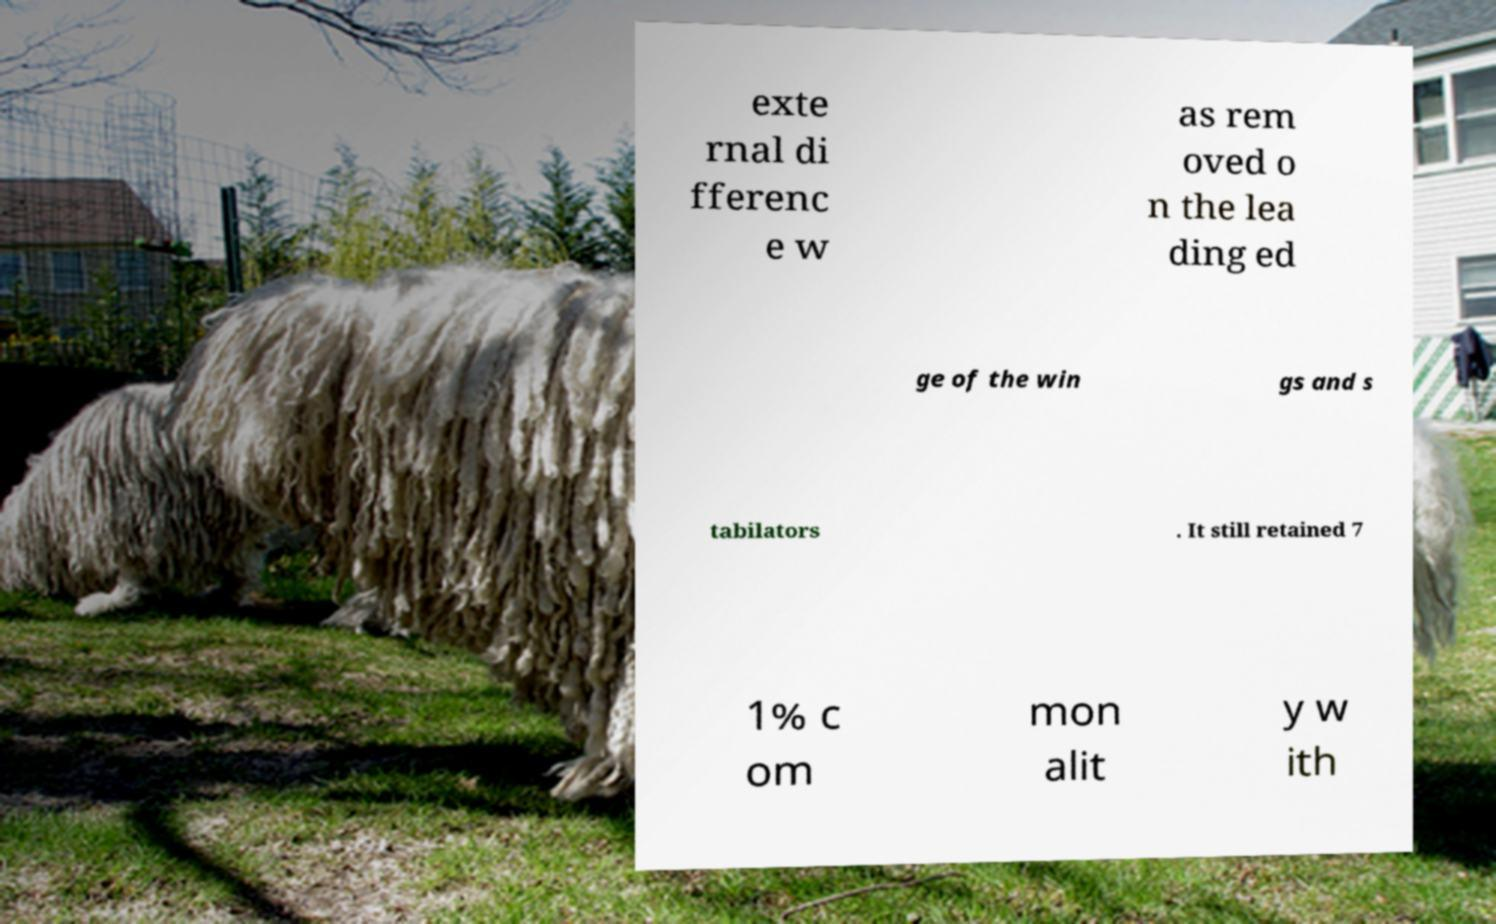There's text embedded in this image that I need extracted. Can you transcribe it verbatim? exte rnal di fferenc e w as rem oved o n the lea ding ed ge of the win gs and s tabilators . It still retained 7 1% c om mon alit y w ith 